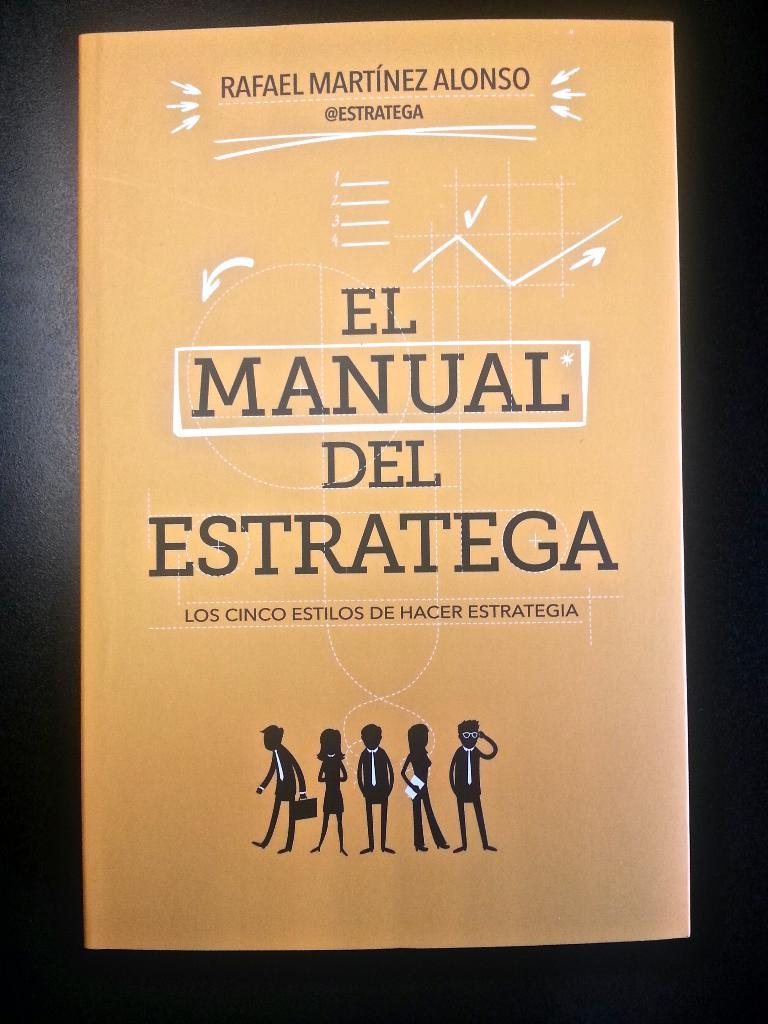<image>
Provide a brief description of the given image. El Manual Del Estratega was written by Rafael Martinez Alonso. 